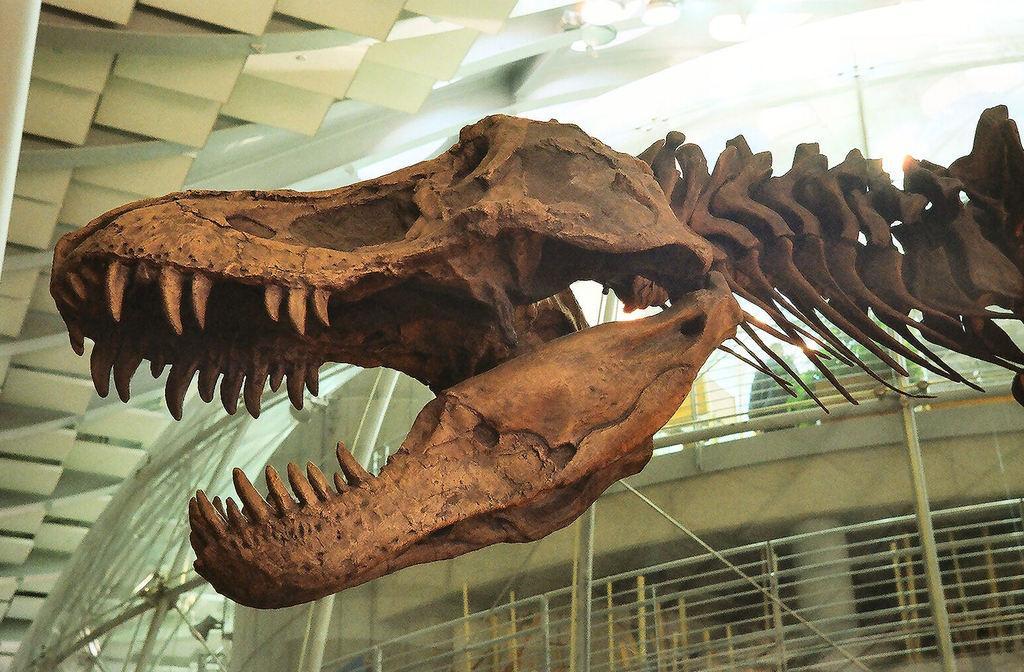Describe this image in one or two sentences. In the image i can see an animal which is brown in color and in the background i can see some lights and other objects. 